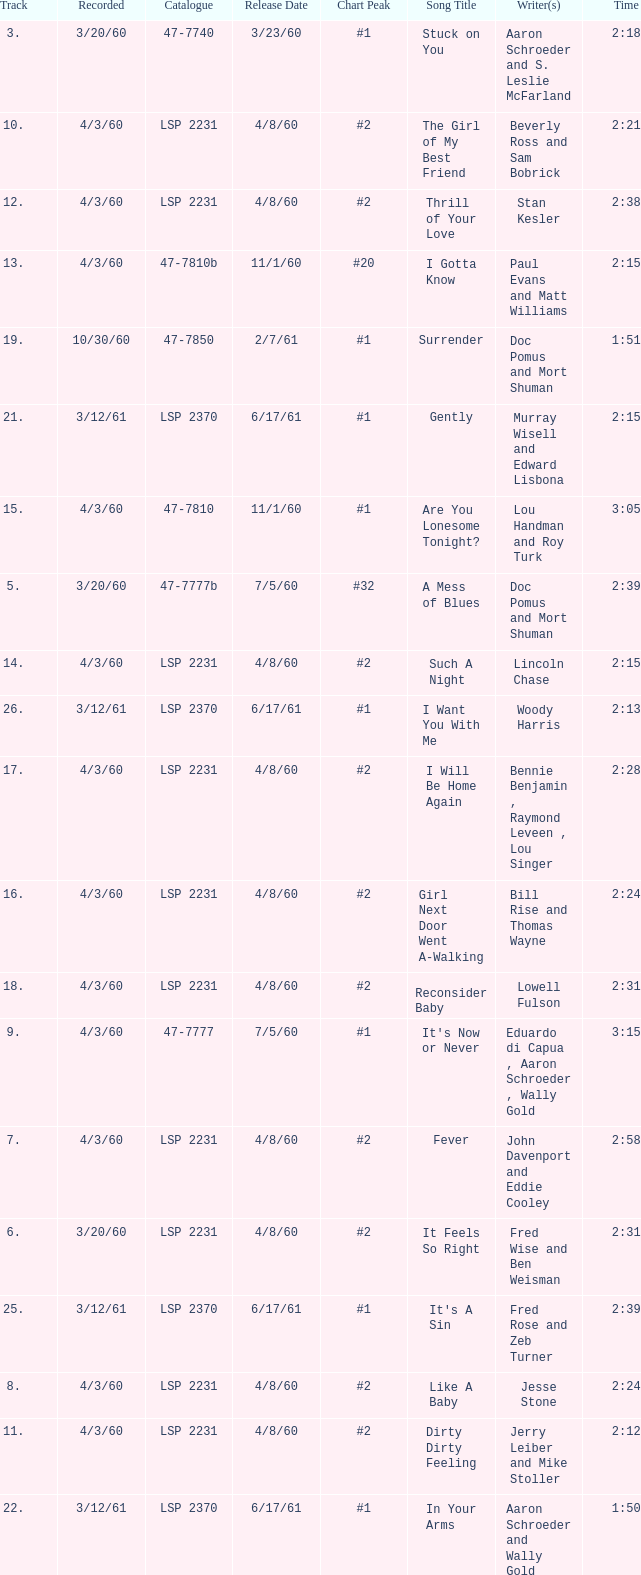In which catalog can the song it's now or never be found? 47-7777. 